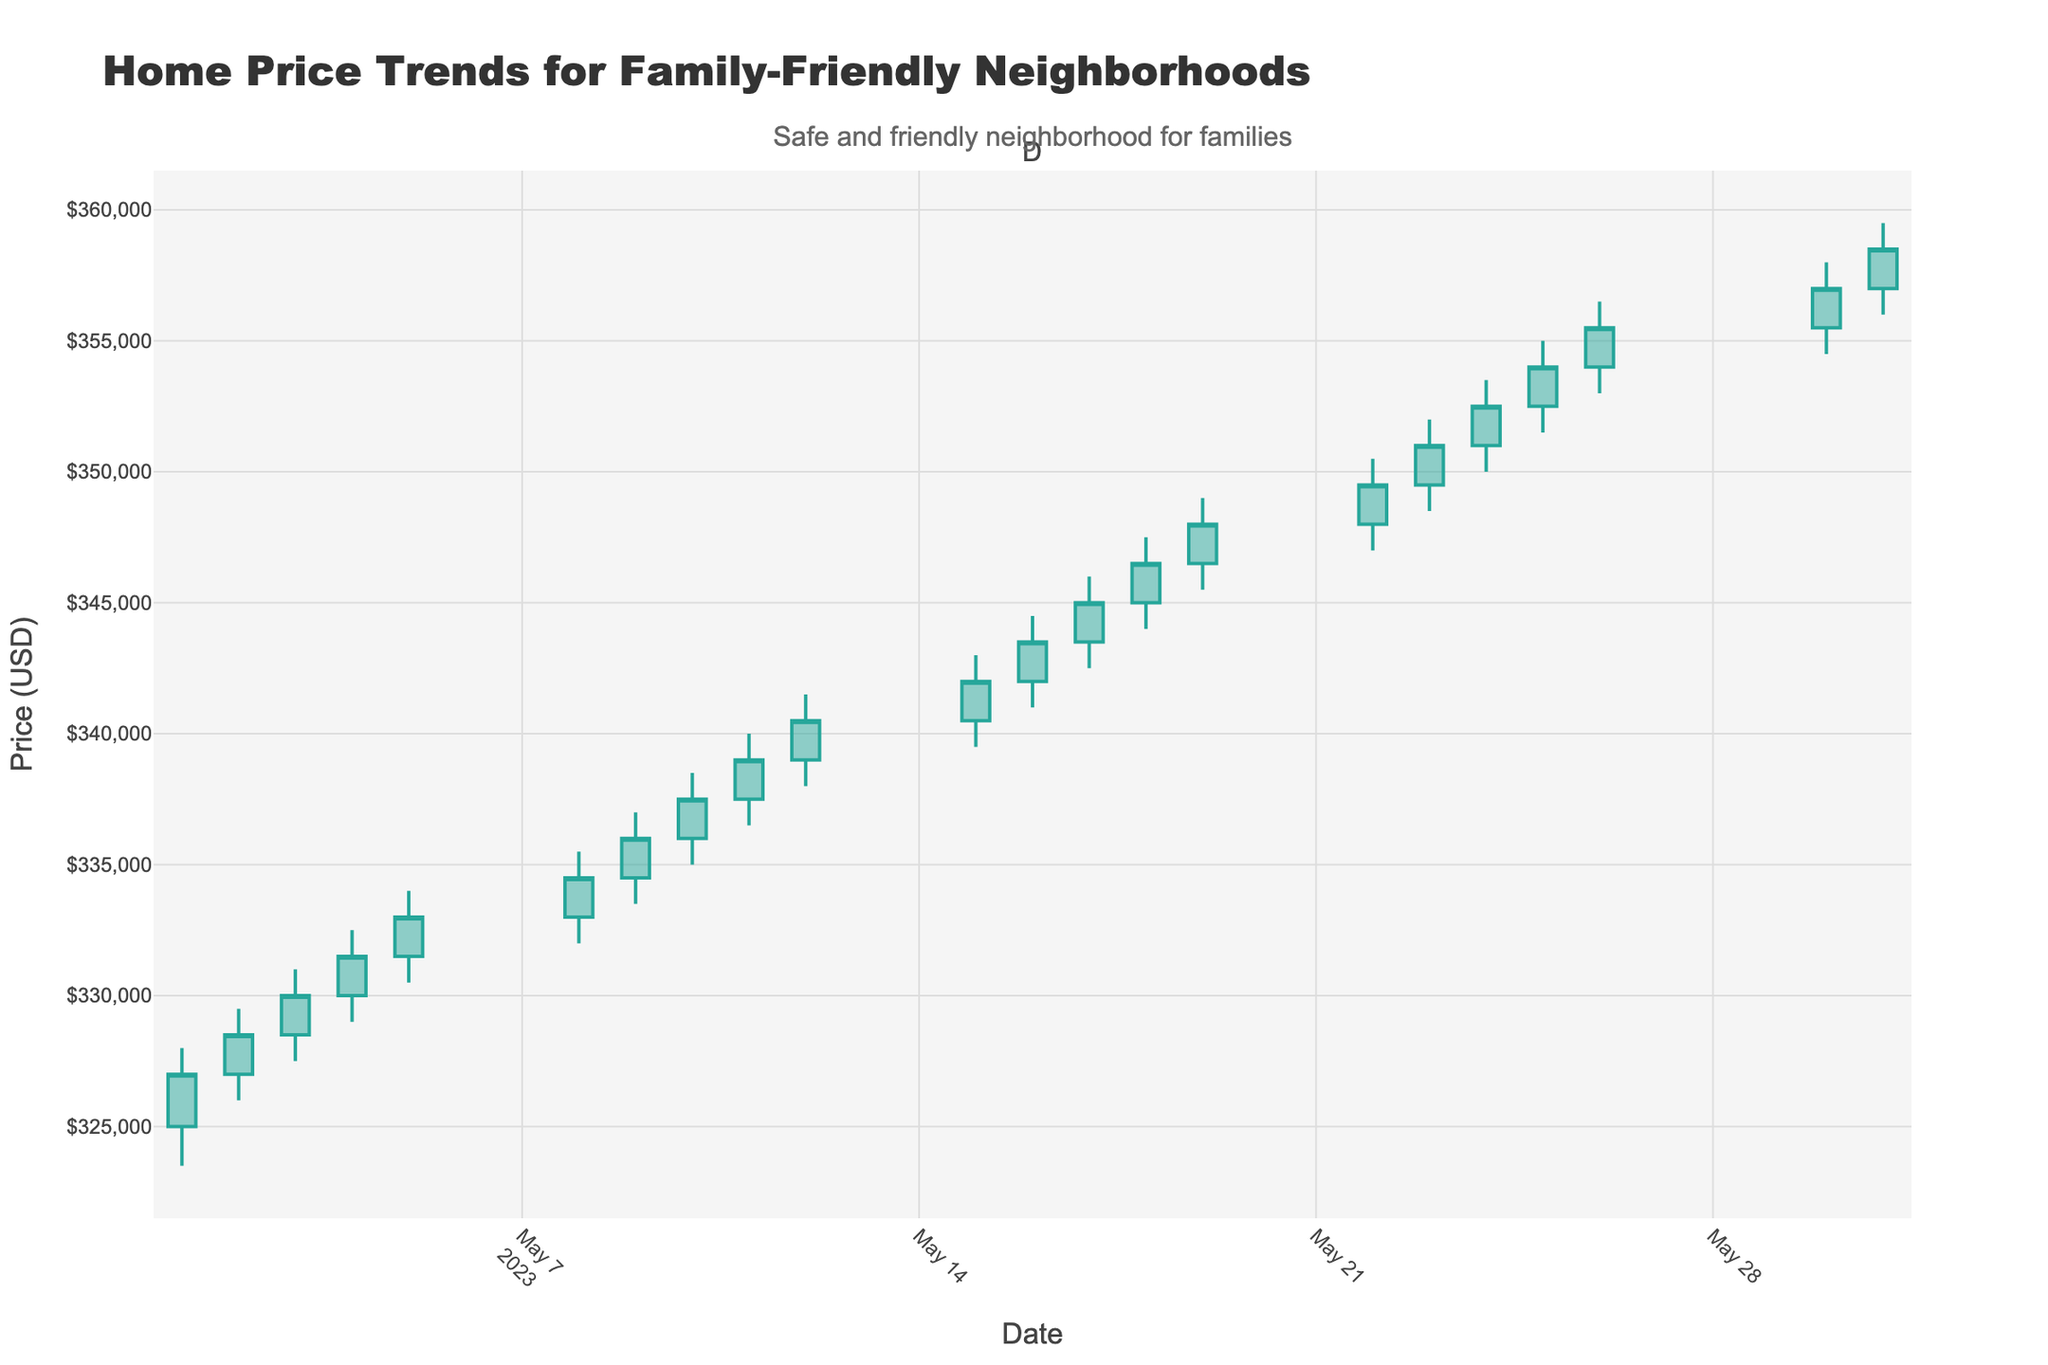What's the title of the chart? The title of the chart is the text at the top that describes what the chart is illustrating.
Answer: Home Price Trends for Family-Friendly Neighborhoods What is the highest home price recorded in May 2023? The highest home price can be found by looking at the highest point of the "High" values on the y-axis. This occurs on May 31 when the price reaches $359,500.
Answer: $359,500 What is the lowest home price recorded in May 2023? The lowest home price can be identified by looking at the lowest point of the "Low" value on the y-axis. This occurs on May 1 when the price reaches $323,500.
Answer: $323,500 On which date did the home prices open at $354,000? To find the date the home prices opened at $354,000, look at the "Open" value in the chart that matches $354,000. It occurs on May 25.
Answer: May 25 How many peaks in price can be identified throughout the month? To determine the number of peaks, count the number of distinct days where home prices have high points. There are several peaks on May 1, 3, 5, 8, 11, 15, 18, 22, 24, 26, 30, and 31, which means there are 12 peaks.
Answer: 12 What is the overall trend of home prices throughout May 2023? By visually observing the candlestick chart, the general direction can be seen. The overall trend shows an increase from early May to the end of the month.
Answer: Increasing Which date had the smallest difference between the day's high and low prices? To find the date with the smallest difference between high and low, subtract the low from the high for each day and identify the minimum difference. The smallest difference occurs on May 16 with a difference of $3,500 ($344,500 - $341,000).
Answer: May 16 Comparing May 10 and May 11, which date had a higher closing price? By comparing the "Close" values of both dates, it's clear that May 11 had a higher closing price ($339,000) compared to May 10 ($337,500).
Answer: May 11 What is the average closing price over the month? To find the average closing price, add all the closing prices and divide by the number of days. The sum of the closing prices from May 1 to May 31 divided by 21 gives the average. So, (327000 + 328500 + 330000 + 331500 + 333000 + 334500 + 336000 + 337500 + 339000 + 340500 + 342000 + 343500 + 345000 + 346500 + 348000 + 349500 + 351000 + 352500 + 354000 + 355500 + 358500)/21 = 341285.71.
Answer: $341,285.71 